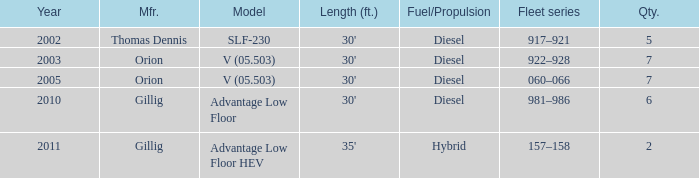Name the fleet series with a quantity of 5 917–921. 